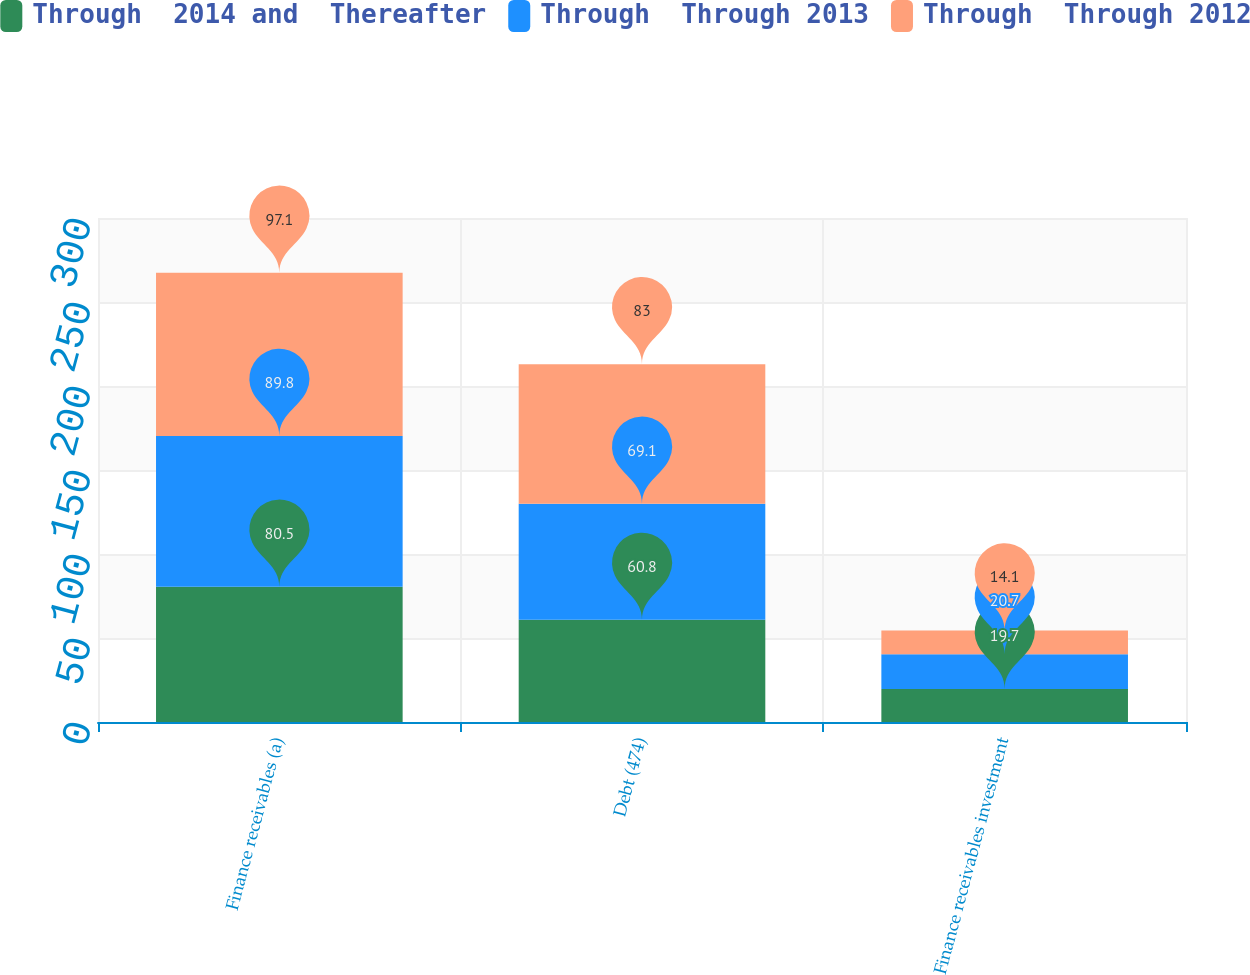Convert chart to OTSL. <chart><loc_0><loc_0><loc_500><loc_500><stacked_bar_chart><ecel><fcel>Finance receivables (a)<fcel>Debt (474)<fcel>Finance receivables investment<nl><fcel>Through  2014 and  Thereafter<fcel>80.5<fcel>60.8<fcel>19.7<nl><fcel>Through  Through 2013<fcel>89.8<fcel>69.1<fcel>20.7<nl><fcel>Through  Through 2012<fcel>97.1<fcel>83<fcel>14.1<nl></chart> 